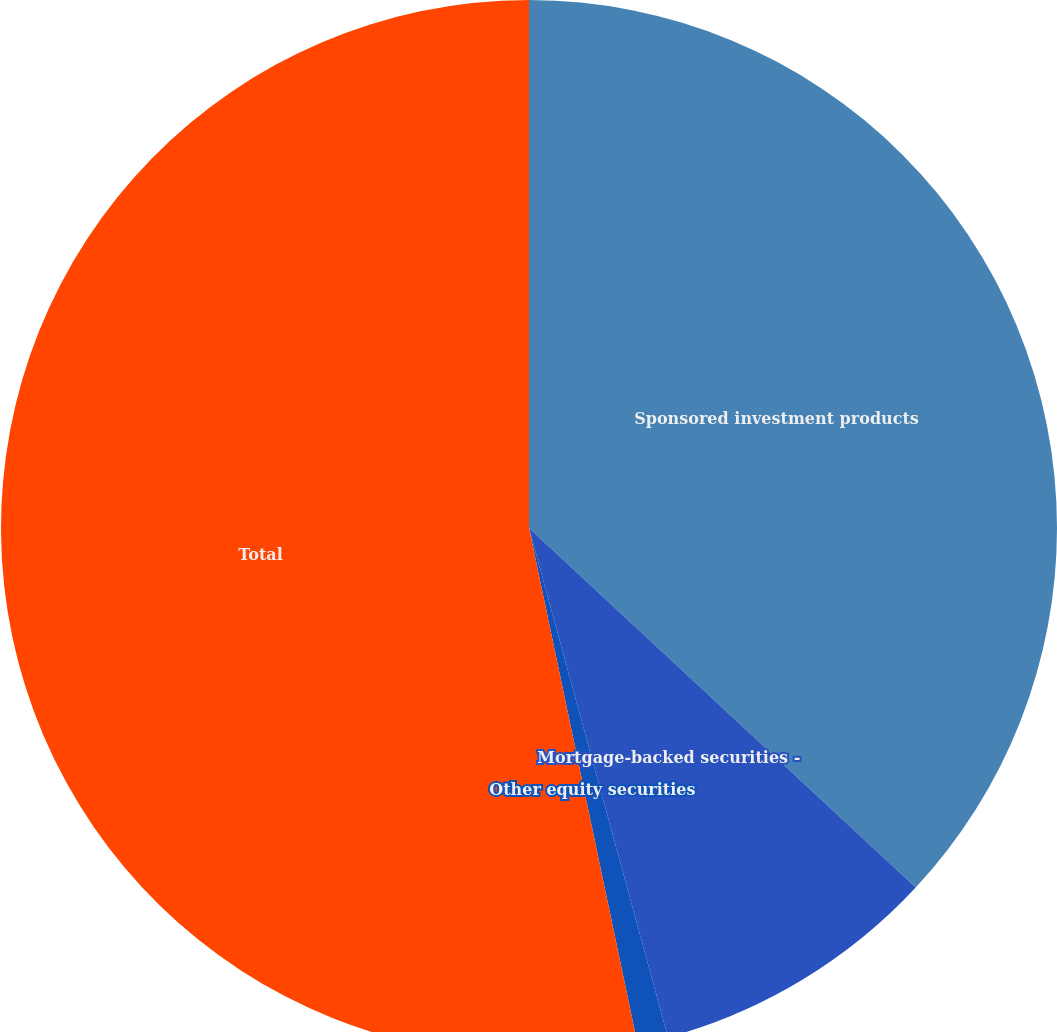Convert chart to OTSL. <chart><loc_0><loc_0><loc_500><loc_500><pie_chart><fcel>Sponsored investment products<fcel>Mortgage-backed securities -<fcel>Other equity securities<fcel>Total<nl><fcel>36.92%<fcel>8.84%<fcel>0.94%<fcel>53.3%<nl></chart> 